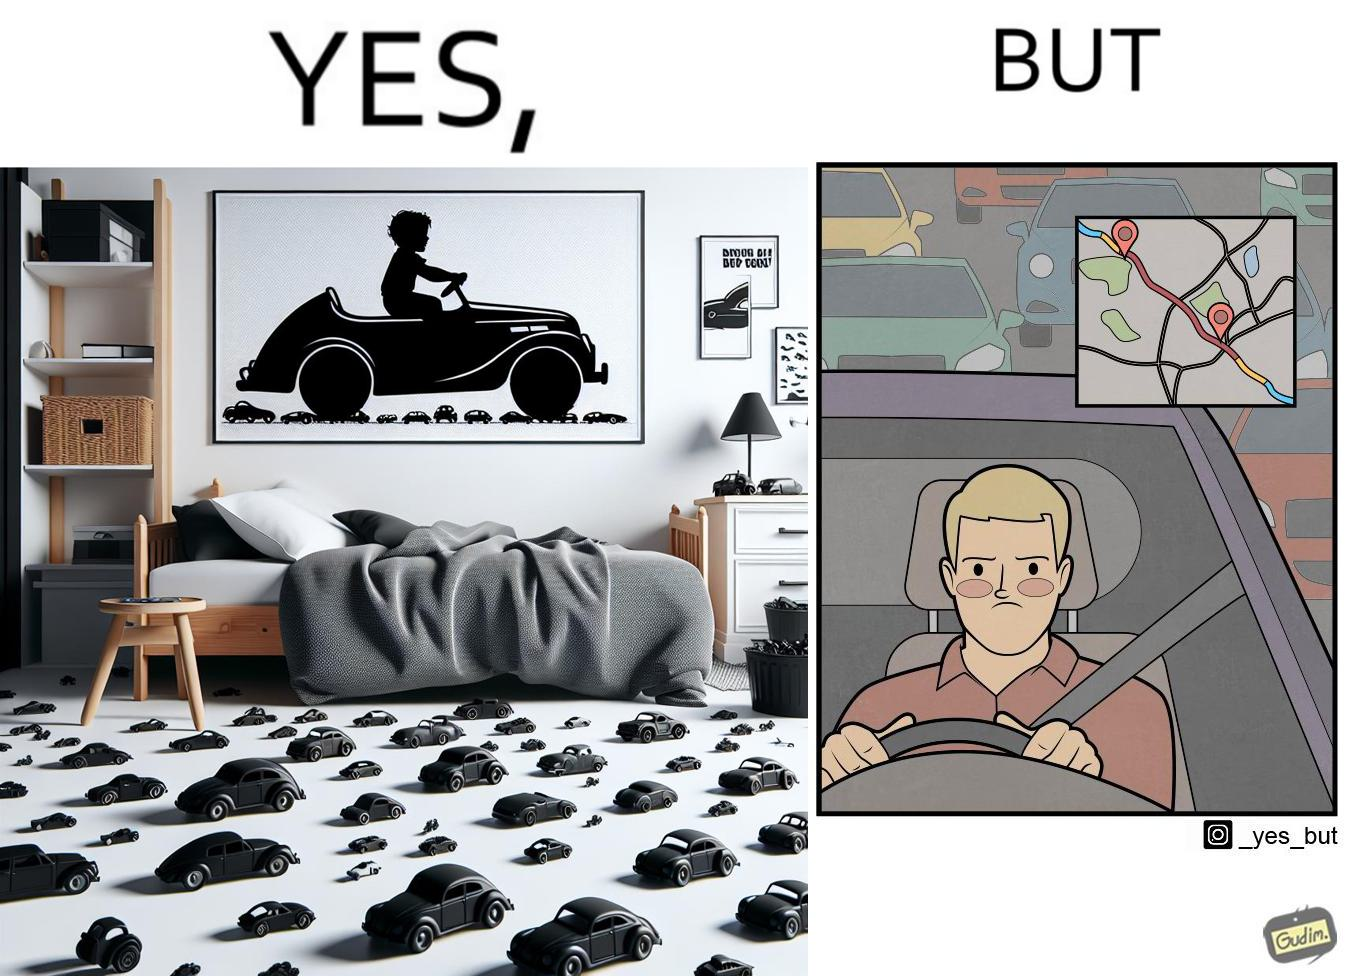Compare the left and right sides of this image. In the left part of the image: The image shows the bedroom of a child with various small toy cars and posters of cars on the wall. The child in the picture is also riding a bigger toy car. In the right part of the image: The image shows a man annoyed by the slow traffic on his way as shown on the map while he is driving. 